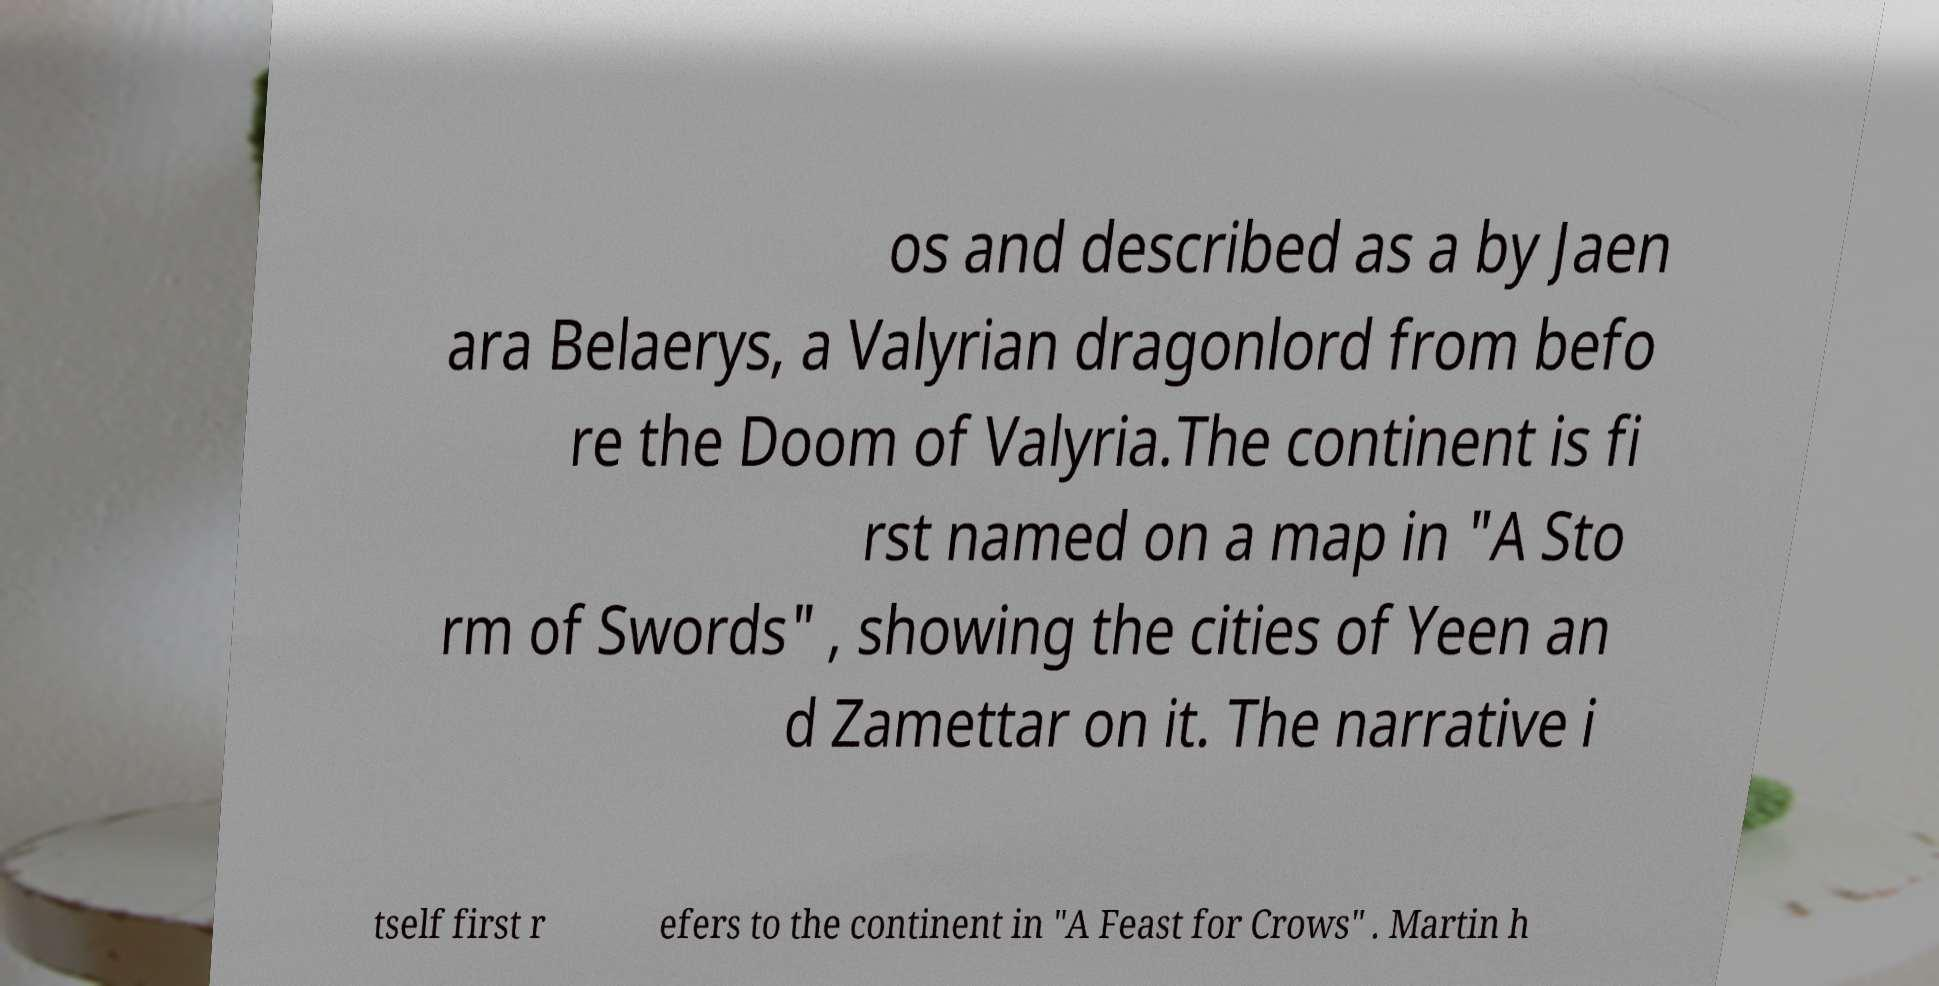Please identify and transcribe the text found in this image. os and described as a by Jaen ara Belaerys, a Valyrian dragonlord from befo re the Doom of Valyria.The continent is fi rst named on a map in "A Sto rm of Swords" , showing the cities of Yeen an d Zamettar on it. The narrative i tself first r efers to the continent in "A Feast for Crows" . Martin h 